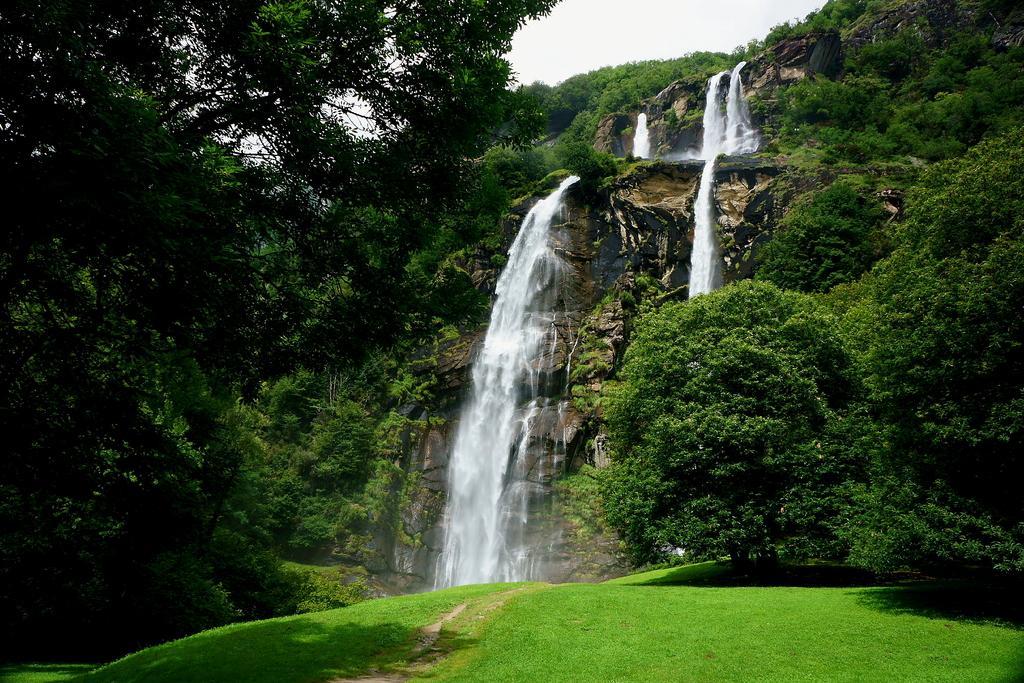Describe this image in one or two sentences. In this image I can see the grass, the ground and few trees. In the background I can see a mountain, the water falling from the mountain, few trees on the mountain and the sky. 